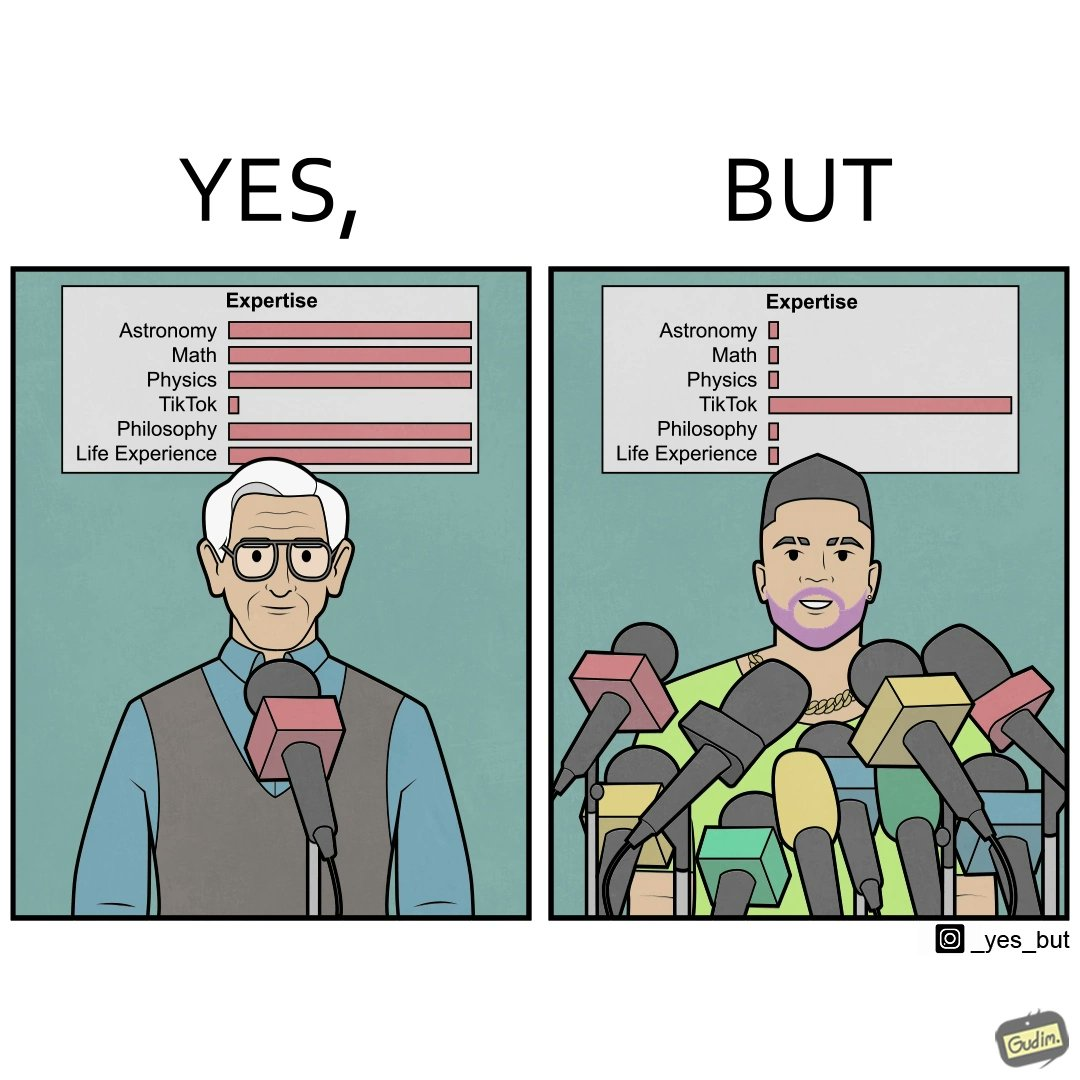What is shown in this image? The image is satirical beacause it shows that people with more tiktok expertise are treated more importantly than the ones who are expert in all the other areas but tiktok. Here, the number of microphones a man speaks into is indicative of his importance. 